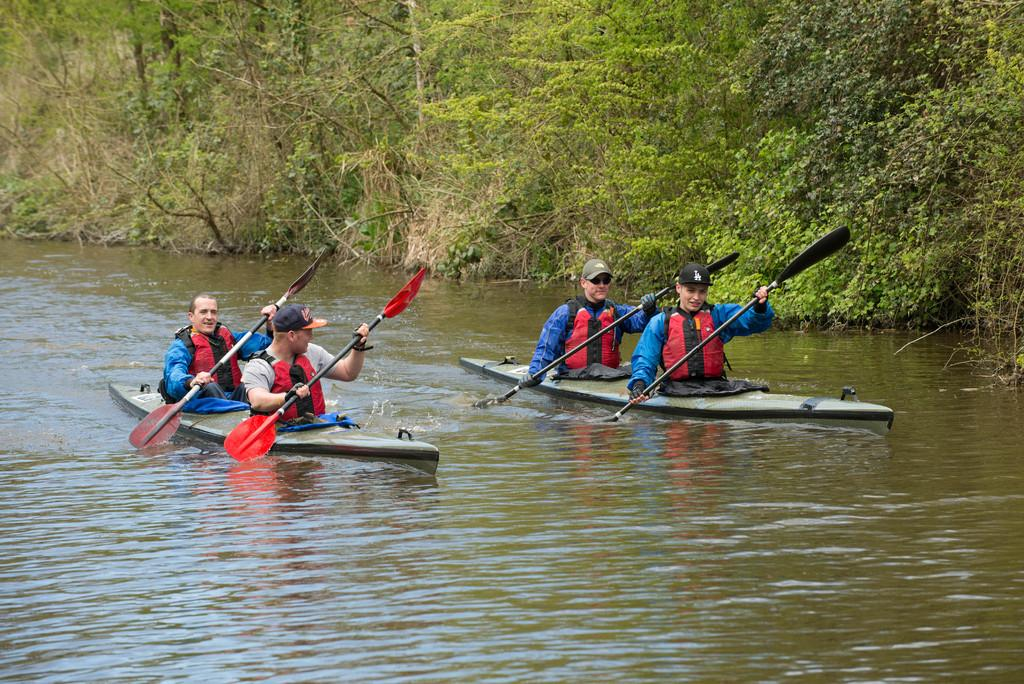What can be seen in the image related to water transportation? There are two boats in the image. Where are the boats located? The boats are on the water. How many people are on the boats? There are four men on the boats. What are the men holding in their hands? The men are holding paddles. How are the men gripping the paddles? The men are using their hands to hold the paddles. What can be seen in the background of the image? There are trees visible in the background of the image. What type of finger competition is taking place between the men on the boats? There is no finger competition present in the image; the men are holding paddles and using them to navigate the boats. 